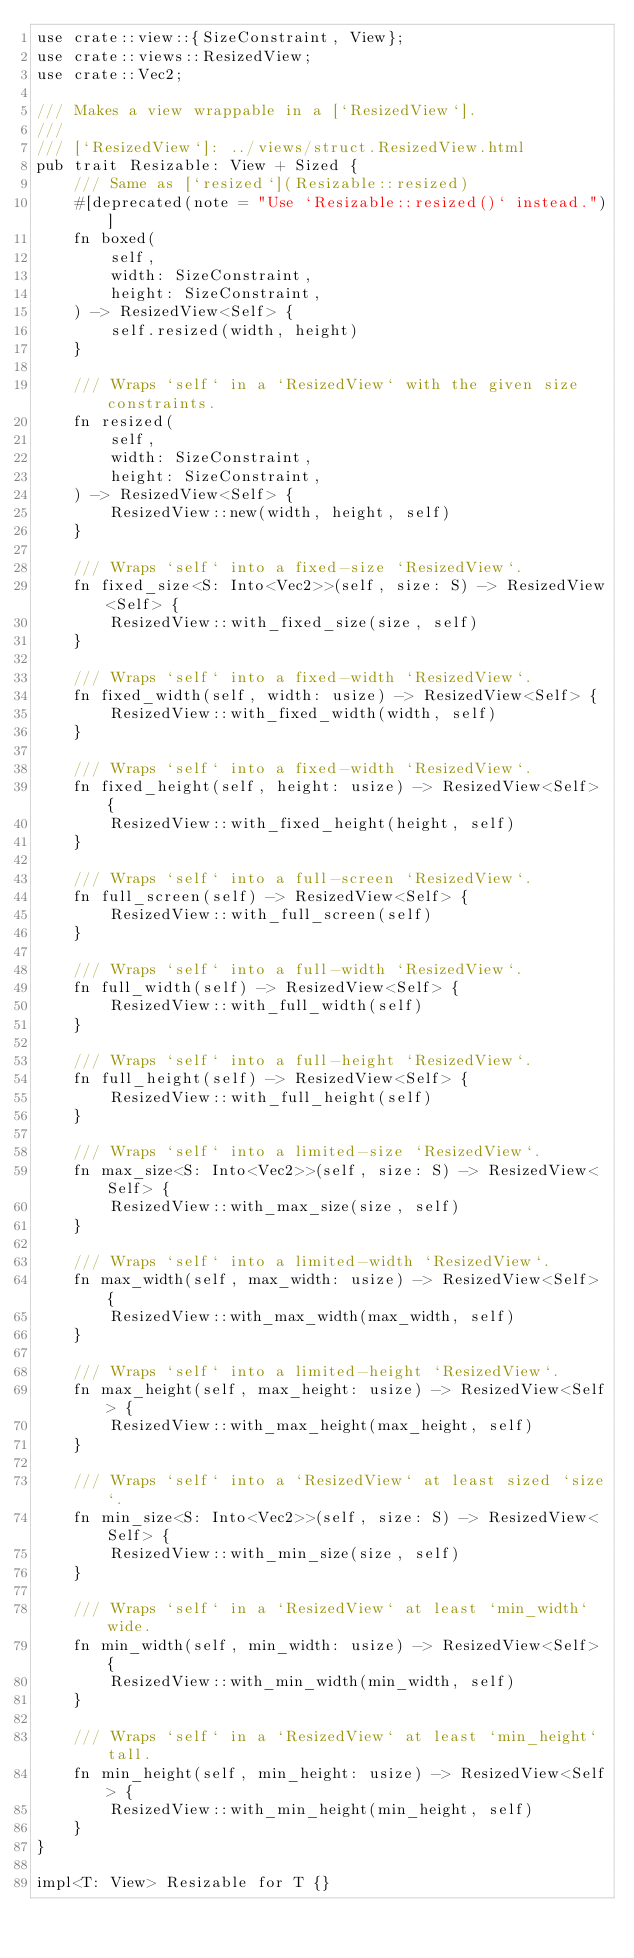Convert code to text. <code><loc_0><loc_0><loc_500><loc_500><_Rust_>use crate::view::{SizeConstraint, View};
use crate::views::ResizedView;
use crate::Vec2;

/// Makes a view wrappable in a [`ResizedView`].
///
/// [`ResizedView`]: ../views/struct.ResizedView.html
pub trait Resizable: View + Sized {
    /// Same as [`resized`](Resizable::resized)
    #[deprecated(note = "Use `Resizable::resized()` instead.")]
    fn boxed(
        self,
        width: SizeConstraint,
        height: SizeConstraint,
    ) -> ResizedView<Self> {
        self.resized(width, height)
    }

    /// Wraps `self` in a `ResizedView` with the given size constraints.
    fn resized(
        self,
        width: SizeConstraint,
        height: SizeConstraint,
    ) -> ResizedView<Self> {
        ResizedView::new(width, height, self)
    }

    /// Wraps `self` into a fixed-size `ResizedView`.
    fn fixed_size<S: Into<Vec2>>(self, size: S) -> ResizedView<Self> {
        ResizedView::with_fixed_size(size, self)
    }

    /// Wraps `self` into a fixed-width `ResizedView`.
    fn fixed_width(self, width: usize) -> ResizedView<Self> {
        ResizedView::with_fixed_width(width, self)
    }

    /// Wraps `self` into a fixed-width `ResizedView`.
    fn fixed_height(self, height: usize) -> ResizedView<Self> {
        ResizedView::with_fixed_height(height, self)
    }

    /// Wraps `self` into a full-screen `ResizedView`.
    fn full_screen(self) -> ResizedView<Self> {
        ResizedView::with_full_screen(self)
    }

    /// Wraps `self` into a full-width `ResizedView`.
    fn full_width(self) -> ResizedView<Self> {
        ResizedView::with_full_width(self)
    }

    /// Wraps `self` into a full-height `ResizedView`.
    fn full_height(self) -> ResizedView<Self> {
        ResizedView::with_full_height(self)
    }

    /// Wraps `self` into a limited-size `ResizedView`.
    fn max_size<S: Into<Vec2>>(self, size: S) -> ResizedView<Self> {
        ResizedView::with_max_size(size, self)
    }

    /// Wraps `self` into a limited-width `ResizedView`.
    fn max_width(self, max_width: usize) -> ResizedView<Self> {
        ResizedView::with_max_width(max_width, self)
    }

    /// Wraps `self` into a limited-height `ResizedView`.
    fn max_height(self, max_height: usize) -> ResizedView<Self> {
        ResizedView::with_max_height(max_height, self)
    }

    /// Wraps `self` into a `ResizedView` at least sized `size`.
    fn min_size<S: Into<Vec2>>(self, size: S) -> ResizedView<Self> {
        ResizedView::with_min_size(size, self)
    }

    /// Wraps `self` in a `ResizedView` at least `min_width` wide.
    fn min_width(self, min_width: usize) -> ResizedView<Self> {
        ResizedView::with_min_width(min_width, self)
    }

    /// Wraps `self` in a `ResizedView` at least `min_height` tall.
    fn min_height(self, min_height: usize) -> ResizedView<Self> {
        ResizedView::with_min_height(min_height, self)
    }
}

impl<T: View> Resizable for T {}
</code> 